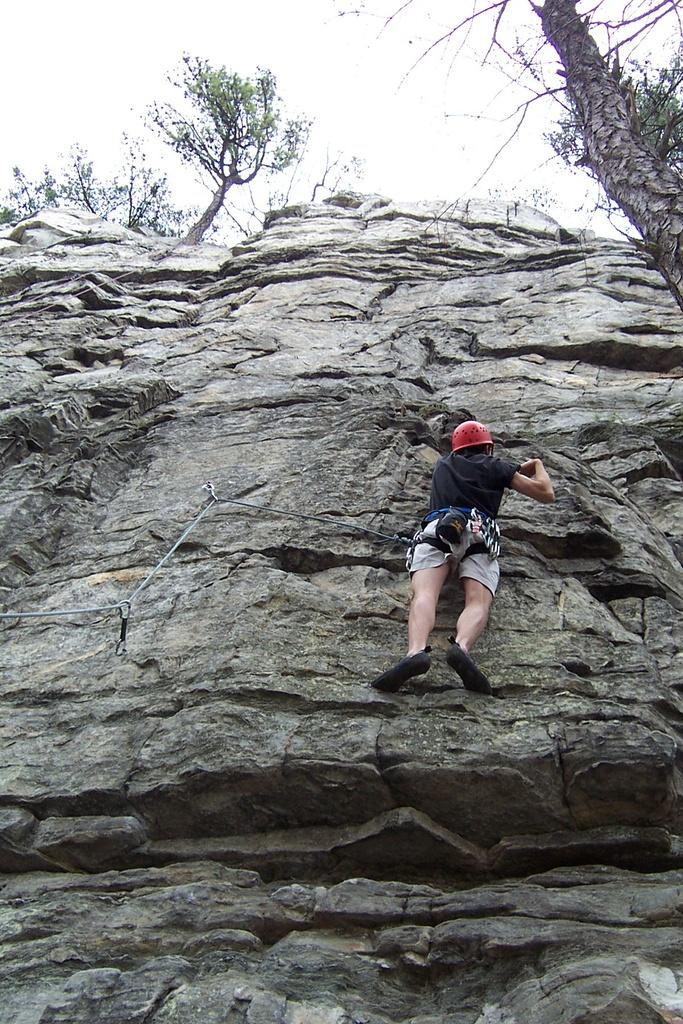What activity is the person in the image engaged in? The person is trekking on a mountain. What can be seen in the background of the image? There are trees and the sky visible in the background of the image. What protective gear is the person wearing? The person is wearing a helmet. How many turkeys can be seen in the image? There are no turkeys present in the image. What type of sink is visible in the image? There is no sink present in the image. 